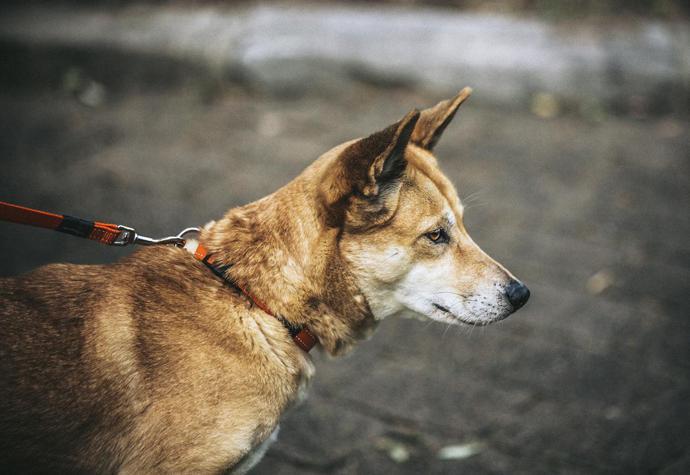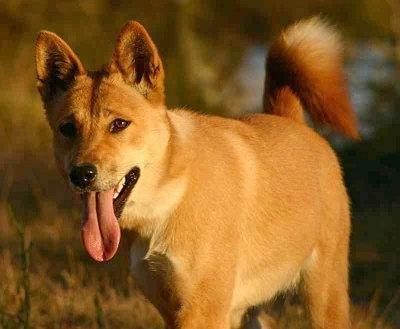The first image is the image on the left, the second image is the image on the right. Examine the images to the left and right. Is the description "A dog is standing on all fours on something made of cement." accurate? Answer yes or no. No. The first image is the image on the left, the second image is the image on the right. For the images displayed, is the sentence "Only one dog has its mouth open." factually correct? Answer yes or no. Yes. 